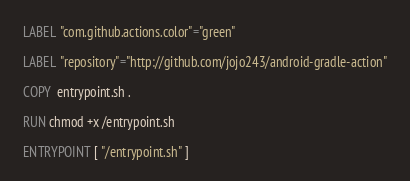<code> <loc_0><loc_0><loc_500><loc_500><_Dockerfile_>LABEL "com.github.actions.color"="green"

LABEL "repository"="http://github.com/jojo243/android-gradle-action"

COPY  entrypoint.sh .

RUN chmod +x /entrypoint.sh

ENTRYPOINT [ "/entrypoint.sh" ]
</code> 